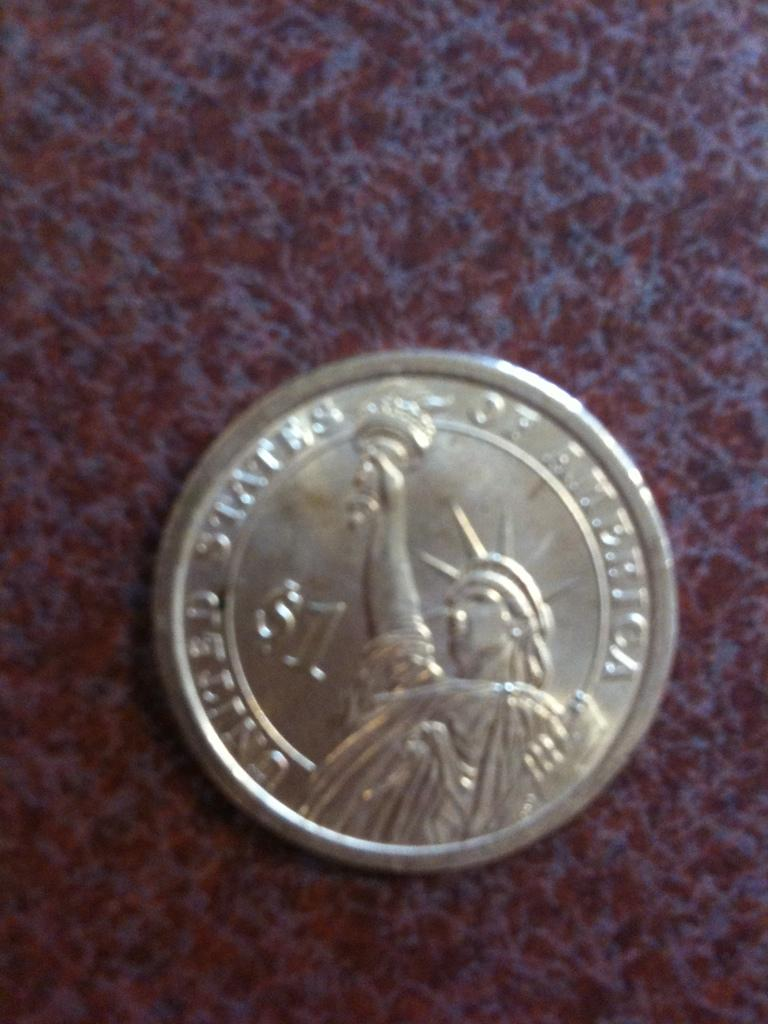<image>
Summarize the visual content of the image. a round silver coin with the united states of america written on it 